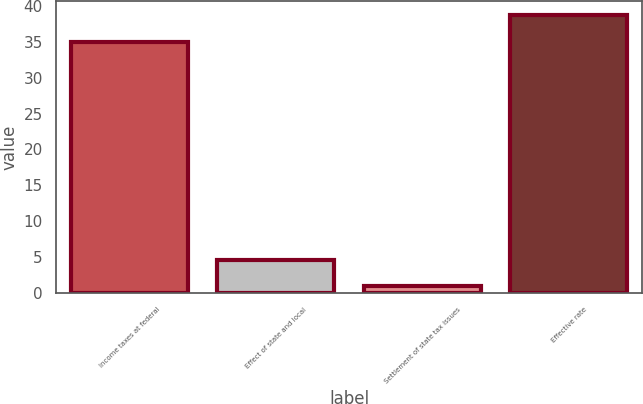Convert chart to OTSL. <chart><loc_0><loc_0><loc_500><loc_500><bar_chart><fcel>Income taxes at federal<fcel>Effect of state and local<fcel>Settlement of state tax issues<fcel>Effective rate<nl><fcel>35<fcel>4.66<fcel>0.96<fcel>38.7<nl></chart> 